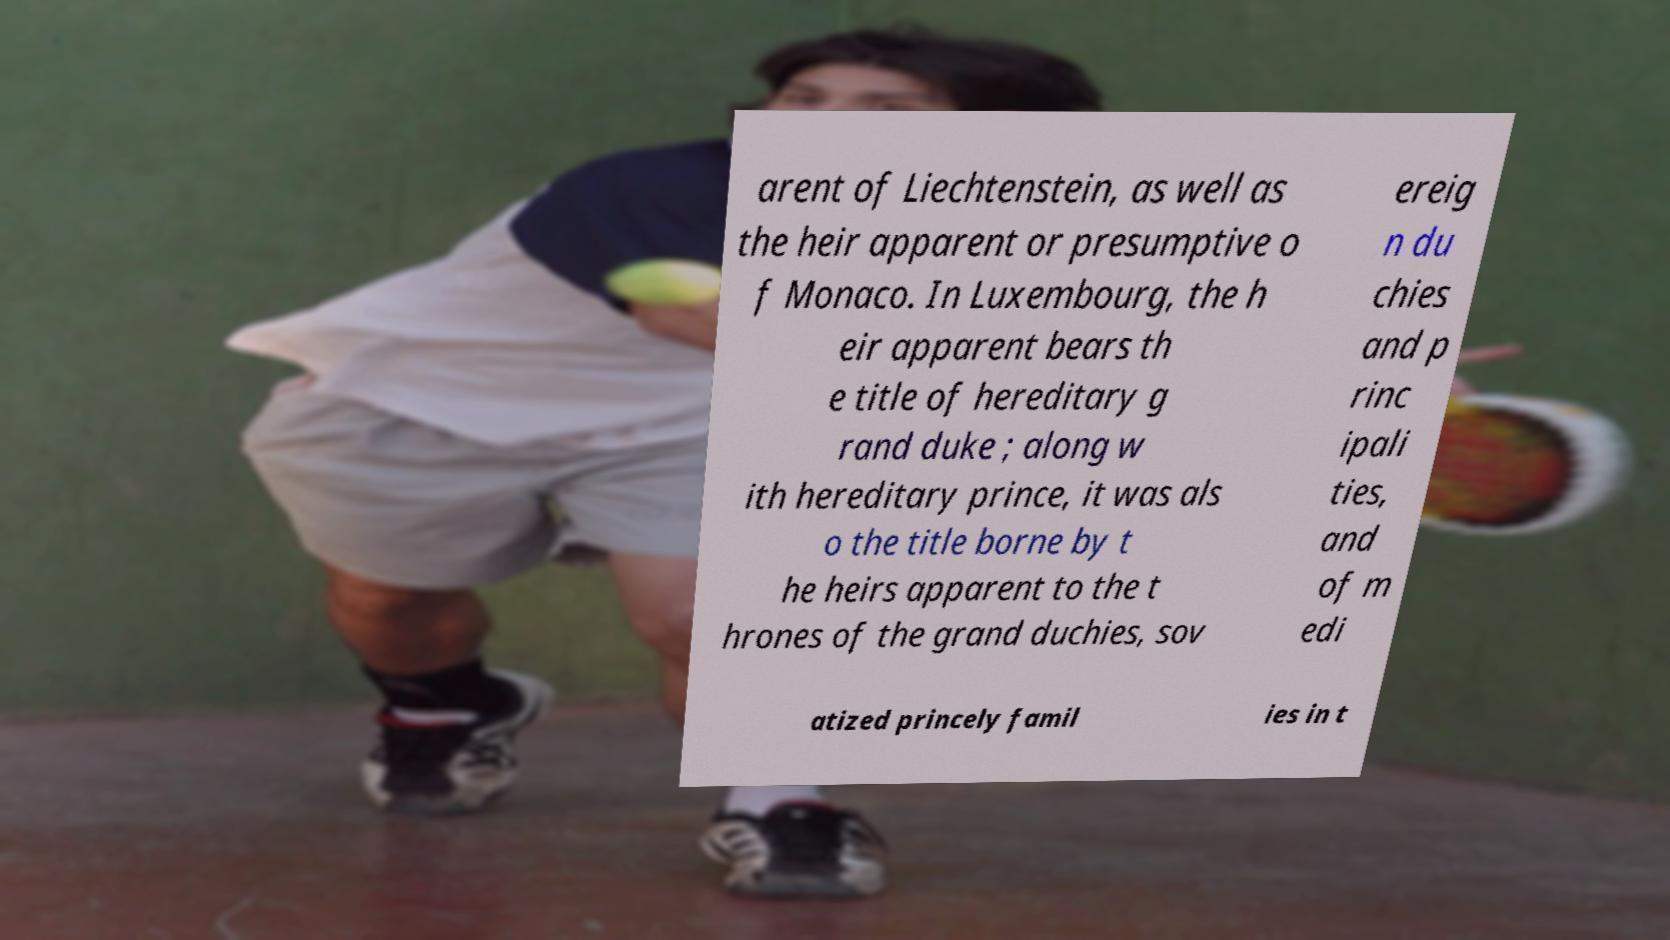Can you accurately transcribe the text from the provided image for me? arent of Liechtenstein, as well as the heir apparent or presumptive o f Monaco. In Luxembourg, the h eir apparent bears th e title of hereditary g rand duke ; along w ith hereditary prince, it was als o the title borne by t he heirs apparent to the t hrones of the grand duchies, sov ereig n du chies and p rinc ipali ties, and of m edi atized princely famil ies in t 